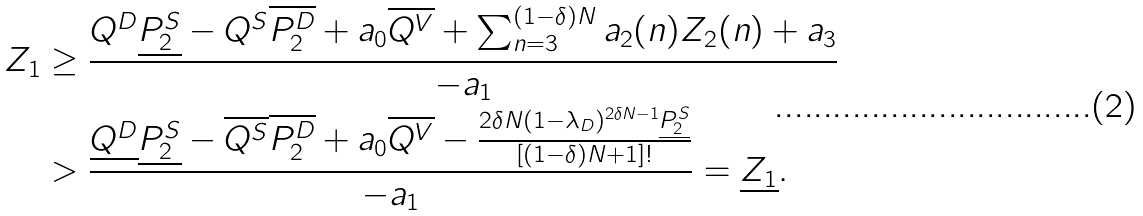<formula> <loc_0><loc_0><loc_500><loc_500>Z _ { 1 } & \geq \frac { Q ^ { D } \underline { P _ { 2 } ^ { S } } - Q ^ { S } \overline { P _ { 2 } ^ { D } } + a _ { 0 } \overline { Q ^ { V } } + \sum _ { n = 3 } ^ { ( 1 - \delta ) N } a _ { 2 } ( n ) Z _ { 2 } ( n ) + a _ { 3 } } { - a _ { 1 } } \\ & > \frac { \underline { Q ^ { D } } \underline { P _ { 2 } ^ { S } } - \overline { Q ^ { S } } \overline { P _ { 2 } ^ { D } } + a _ { 0 } \overline { Q ^ { V } } - \frac { 2 \delta N ( 1 - \lambda _ { D } ) ^ { 2 \delta N - 1 } \underline { P _ { 2 } ^ { S } } } { [ ( 1 - \delta ) N + 1 ] ! } } { - a _ { 1 } } = \underline { Z _ { 1 } } .</formula> 